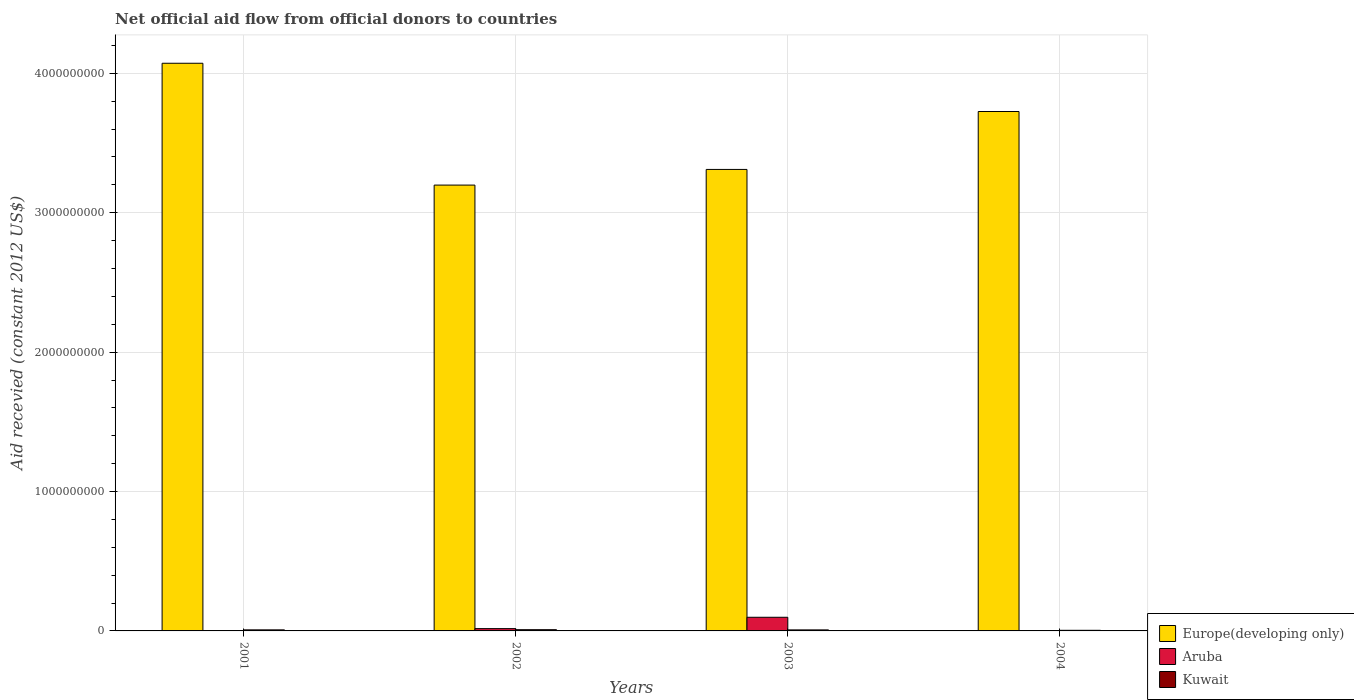How many groups of bars are there?
Keep it short and to the point. 4. Are the number of bars per tick equal to the number of legend labels?
Provide a short and direct response. No. How many bars are there on the 3rd tick from the left?
Offer a very short reply. 3. What is the label of the 3rd group of bars from the left?
Provide a succinct answer. 2003. In how many cases, is the number of bars for a given year not equal to the number of legend labels?
Offer a very short reply. 2. What is the total aid received in Aruba in 2003?
Your response must be concise. 9.79e+07. Across all years, what is the maximum total aid received in Aruba?
Provide a succinct answer. 9.79e+07. Across all years, what is the minimum total aid received in Kuwait?
Offer a terse response. 4.44e+06. In which year was the total aid received in Kuwait maximum?
Keep it short and to the point. 2002. What is the total total aid received in Kuwait in the graph?
Give a very brief answer. 2.82e+07. What is the difference between the total aid received in Kuwait in 2003 and the total aid received in Europe(developing only) in 2002?
Give a very brief answer. -3.19e+09. What is the average total aid received in Aruba per year?
Provide a short and direct response. 2.86e+07. In the year 2003, what is the difference between the total aid received in Kuwait and total aid received in Aruba?
Offer a very short reply. -9.06e+07. In how many years, is the total aid received in Aruba greater than 1400000000 US$?
Provide a short and direct response. 0. What is the ratio of the total aid received in Europe(developing only) in 2002 to that in 2003?
Keep it short and to the point. 0.97. Is the difference between the total aid received in Kuwait in 2002 and 2003 greater than the difference between the total aid received in Aruba in 2002 and 2003?
Give a very brief answer. Yes. What is the difference between the highest and the second highest total aid received in Kuwait?
Ensure brevity in your answer.  1.22e+06. What is the difference between the highest and the lowest total aid received in Aruba?
Your answer should be compact. 9.79e+07. In how many years, is the total aid received in Kuwait greater than the average total aid received in Kuwait taken over all years?
Offer a very short reply. 3. Is the sum of the total aid received in Kuwait in 2002 and 2004 greater than the maximum total aid received in Aruba across all years?
Your answer should be compact. No. Is it the case that in every year, the sum of the total aid received in Europe(developing only) and total aid received in Aruba is greater than the total aid received in Kuwait?
Your answer should be very brief. Yes. How many bars are there?
Offer a terse response. 10. Are all the bars in the graph horizontal?
Ensure brevity in your answer.  No. Are the values on the major ticks of Y-axis written in scientific E-notation?
Your answer should be very brief. No. Does the graph contain any zero values?
Provide a short and direct response. Yes. Where does the legend appear in the graph?
Provide a short and direct response. Bottom right. How many legend labels are there?
Offer a terse response. 3. What is the title of the graph?
Provide a succinct answer. Net official aid flow from official donors to countries. Does "Tanzania" appear as one of the legend labels in the graph?
Your response must be concise. No. What is the label or title of the Y-axis?
Make the answer very short. Aid recevied (constant 2012 US$). What is the Aid recevied (constant 2012 US$) of Europe(developing only) in 2001?
Ensure brevity in your answer.  4.07e+09. What is the Aid recevied (constant 2012 US$) of Kuwait in 2001?
Provide a short and direct response. 7.60e+06. What is the Aid recevied (constant 2012 US$) in Europe(developing only) in 2002?
Your answer should be very brief. 3.20e+09. What is the Aid recevied (constant 2012 US$) of Aruba in 2002?
Keep it short and to the point. 1.65e+07. What is the Aid recevied (constant 2012 US$) in Kuwait in 2002?
Offer a terse response. 8.82e+06. What is the Aid recevied (constant 2012 US$) of Europe(developing only) in 2003?
Ensure brevity in your answer.  3.31e+09. What is the Aid recevied (constant 2012 US$) of Aruba in 2003?
Offer a very short reply. 9.79e+07. What is the Aid recevied (constant 2012 US$) in Kuwait in 2003?
Your answer should be compact. 7.34e+06. What is the Aid recevied (constant 2012 US$) in Europe(developing only) in 2004?
Provide a succinct answer. 3.73e+09. What is the Aid recevied (constant 2012 US$) of Kuwait in 2004?
Offer a terse response. 4.44e+06. Across all years, what is the maximum Aid recevied (constant 2012 US$) in Europe(developing only)?
Your answer should be very brief. 4.07e+09. Across all years, what is the maximum Aid recevied (constant 2012 US$) in Aruba?
Provide a succinct answer. 9.79e+07. Across all years, what is the maximum Aid recevied (constant 2012 US$) of Kuwait?
Keep it short and to the point. 8.82e+06. Across all years, what is the minimum Aid recevied (constant 2012 US$) of Europe(developing only)?
Make the answer very short. 3.20e+09. Across all years, what is the minimum Aid recevied (constant 2012 US$) of Aruba?
Keep it short and to the point. 0. Across all years, what is the minimum Aid recevied (constant 2012 US$) of Kuwait?
Your response must be concise. 4.44e+06. What is the total Aid recevied (constant 2012 US$) of Europe(developing only) in the graph?
Your answer should be compact. 1.43e+1. What is the total Aid recevied (constant 2012 US$) of Aruba in the graph?
Provide a succinct answer. 1.14e+08. What is the total Aid recevied (constant 2012 US$) of Kuwait in the graph?
Give a very brief answer. 2.82e+07. What is the difference between the Aid recevied (constant 2012 US$) of Europe(developing only) in 2001 and that in 2002?
Keep it short and to the point. 8.74e+08. What is the difference between the Aid recevied (constant 2012 US$) of Kuwait in 2001 and that in 2002?
Your response must be concise. -1.22e+06. What is the difference between the Aid recevied (constant 2012 US$) of Europe(developing only) in 2001 and that in 2003?
Give a very brief answer. 7.62e+08. What is the difference between the Aid recevied (constant 2012 US$) of Europe(developing only) in 2001 and that in 2004?
Provide a short and direct response. 3.46e+08. What is the difference between the Aid recevied (constant 2012 US$) in Kuwait in 2001 and that in 2004?
Your answer should be compact. 3.16e+06. What is the difference between the Aid recevied (constant 2012 US$) of Europe(developing only) in 2002 and that in 2003?
Give a very brief answer. -1.12e+08. What is the difference between the Aid recevied (constant 2012 US$) in Aruba in 2002 and that in 2003?
Your response must be concise. -8.14e+07. What is the difference between the Aid recevied (constant 2012 US$) in Kuwait in 2002 and that in 2003?
Make the answer very short. 1.48e+06. What is the difference between the Aid recevied (constant 2012 US$) of Europe(developing only) in 2002 and that in 2004?
Give a very brief answer. -5.28e+08. What is the difference between the Aid recevied (constant 2012 US$) of Kuwait in 2002 and that in 2004?
Make the answer very short. 4.38e+06. What is the difference between the Aid recevied (constant 2012 US$) in Europe(developing only) in 2003 and that in 2004?
Provide a short and direct response. -4.15e+08. What is the difference between the Aid recevied (constant 2012 US$) in Kuwait in 2003 and that in 2004?
Keep it short and to the point. 2.90e+06. What is the difference between the Aid recevied (constant 2012 US$) of Europe(developing only) in 2001 and the Aid recevied (constant 2012 US$) of Aruba in 2002?
Your response must be concise. 4.06e+09. What is the difference between the Aid recevied (constant 2012 US$) of Europe(developing only) in 2001 and the Aid recevied (constant 2012 US$) of Kuwait in 2002?
Provide a short and direct response. 4.06e+09. What is the difference between the Aid recevied (constant 2012 US$) of Europe(developing only) in 2001 and the Aid recevied (constant 2012 US$) of Aruba in 2003?
Your response must be concise. 3.97e+09. What is the difference between the Aid recevied (constant 2012 US$) of Europe(developing only) in 2001 and the Aid recevied (constant 2012 US$) of Kuwait in 2003?
Your answer should be compact. 4.06e+09. What is the difference between the Aid recevied (constant 2012 US$) of Europe(developing only) in 2001 and the Aid recevied (constant 2012 US$) of Kuwait in 2004?
Ensure brevity in your answer.  4.07e+09. What is the difference between the Aid recevied (constant 2012 US$) in Europe(developing only) in 2002 and the Aid recevied (constant 2012 US$) in Aruba in 2003?
Provide a succinct answer. 3.10e+09. What is the difference between the Aid recevied (constant 2012 US$) of Europe(developing only) in 2002 and the Aid recevied (constant 2012 US$) of Kuwait in 2003?
Offer a very short reply. 3.19e+09. What is the difference between the Aid recevied (constant 2012 US$) of Aruba in 2002 and the Aid recevied (constant 2012 US$) of Kuwait in 2003?
Your response must be concise. 9.17e+06. What is the difference between the Aid recevied (constant 2012 US$) in Europe(developing only) in 2002 and the Aid recevied (constant 2012 US$) in Kuwait in 2004?
Your response must be concise. 3.19e+09. What is the difference between the Aid recevied (constant 2012 US$) in Aruba in 2002 and the Aid recevied (constant 2012 US$) in Kuwait in 2004?
Make the answer very short. 1.21e+07. What is the difference between the Aid recevied (constant 2012 US$) of Europe(developing only) in 2003 and the Aid recevied (constant 2012 US$) of Kuwait in 2004?
Give a very brief answer. 3.31e+09. What is the difference between the Aid recevied (constant 2012 US$) of Aruba in 2003 and the Aid recevied (constant 2012 US$) of Kuwait in 2004?
Your answer should be very brief. 9.35e+07. What is the average Aid recevied (constant 2012 US$) in Europe(developing only) per year?
Your answer should be very brief. 3.58e+09. What is the average Aid recevied (constant 2012 US$) of Aruba per year?
Give a very brief answer. 2.86e+07. What is the average Aid recevied (constant 2012 US$) of Kuwait per year?
Ensure brevity in your answer.  7.05e+06. In the year 2001, what is the difference between the Aid recevied (constant 2012 US$) of Europe(developing only) and Aid recevied (constant 2012 US$) of Kuwait?
Offer a terse response. 4.06e+09. In the year 2002, what is the difference between the Aid recevied (constant 2012 US$) in Europe(developing only) and Aid recevied (constant 2012 US$) in Aruba?
Offer a terse response. 3.18e+09. In the year 2002, what is the difference between the Aid recevied (constant 2012 US$) of Europe(developing only) and Aid recevied (constant 2012 US$) of Kuwait?
Your answer should be compact. 3.19e+09. In the year 2002, what is the difference between the Aid recevied (constant 2012 US$) in Aruba and Aid recevied (constant 2012 US$) in Kuwait?
Provide a short and direct response. 7.69e+06. In the year 2003, what is the difference between the Aid recevied (constant 2012 US$) in Europe(developing only) and Aid recevied (constant 2012 US$) in Aruba?
Your answer should be very brief. 3.21e+09. In the year 2003, what is the difference between the Aid recevied (constant 2012 US$) in Europe(developing only) and Aid recevied (constant 2012 US$) in Kuwait?
Keep it short and to the point. 3.30e+09. In the year 2003, what is the difference between the Aid recevied (constant 2012 US$) in Aruba and Aid recevied (constant 2012 US$) in Kuwait?
Provide a short and direct response. 9.06e+07. In the year 2004, what is the difference between the Aid recevied (constant 2012 US$) in Europe(developing only) and Aid recevied (constant 2012 US$) in Kuwait?
Your response must be concise. 3.72e+09. What is the ratio of the Aid recevied (constant 2012 US$) in Europe(developing only) in 2001 to that in 2002?
Keep it short and to the point. 1.27. What is the ratio of the Aid recevied (constant 2012 US$) of Kuwait in 2001 to that in 2002?
Make the answer very short. 0.86. What is the ratio of the Aid recevied (constant 2012 US$) of Europe(developing only) in 2001 to that in 2003?
Provide a succinct answer. 1.23. What is the ratio of the Aid recevied (constant 2012 US$) in Kuwait in 2001 to that in 2003?
Provide a short and direct response. 1.04. What is the ratio of the Aid recevied (constant 2012 US$) in Europe(developing only) in 2001 to that in 2004?
Offer a terse response. 1.09. What is the ratio of the Aid recevied (constant 2012 US$) of Kuwait in 2001 to that in 2004?
Your response must be concise. 1.71. What is the ratio of the Aid recevied (constant 2012 US$) in Europe(developing only) in 2002 to that in 2003?
Offer a very short reply. 0.97. What is the ratio of the Aid recevied (constant 2012 US$) of Aruba in 2002 to that in 2003?
Ensure brevity in your answer.  0.17. What is the ratio of the Aid recevied (constant 2012 US$) in Kuwait in 2002 to that in 2003?
Your answer should be very brief. 1.2. What is the ratio of the Aid recevied (constant 2012 US$) in Europe(developing only) in 2002 to that in 2004?
Make the answer very short. 0.86. What is the ratio of the Aid recevied (constant 2012 US$) in Kuwait in 2002 to that in 2004?
Your answer should be compact. 1.99. What is the ratio of the Aid recevied (constant 2012 US$) in Europe(developing only) in 2003 to that in 2004?
Provide a succinct answer. 0.89. What is the ratio of the Aid recevied (constant 2012 US$) in Kuwait in 2003 to that in 2004?
Give a very brief answer. 1.65. What is the difference between the highest and the second highest Aid recevied (constant 2012 US$) in Europe(developing only)?
Make the answer very short. 3.46e+08. What is the difference between the highest and the second highest Aid recevied (constant 2012 US$) of Kuwait?
Ensure brevity in your answer.  1.22e+06. What is the difference between the highest and the lowest Aid recevied (constant 2012 US$) in Europe(developing only)?
Offer a terse response. 8.74e+08. What is the difference between the highest and the lowest Aid recevied (constant 2012 US$) in Aruba?
Ensure brevity in your answer.  9.79e+07. What is the difference between the highest and the lowest Aid recevied (constant 2012 US$) of Kuwait?
Offer a terse response. 4.38e+06. 